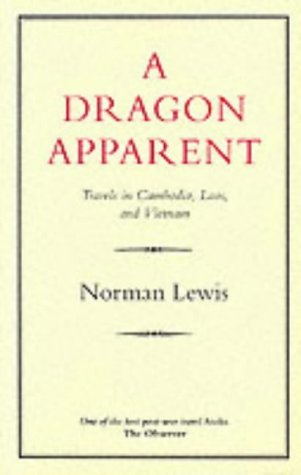Who wrote this book? The author of the book 'A Dragon Apparent' is Norman Lewis, an acclaimed travel writer known for his insightful explorations. 